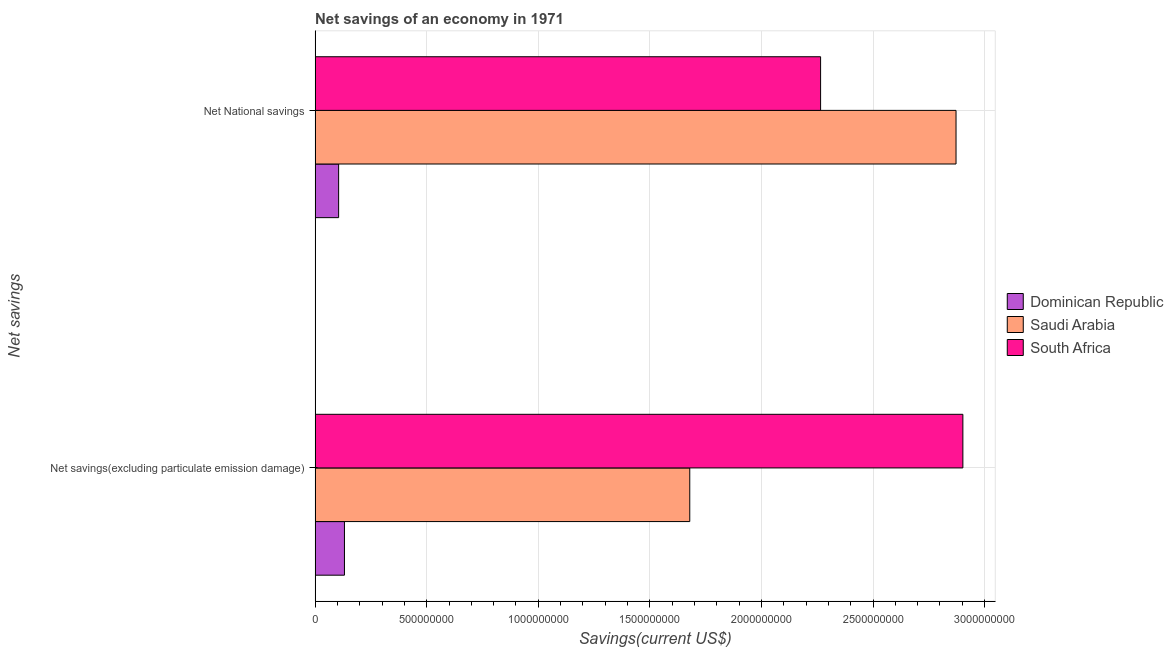How many groups of bars are there?
Ensure brevity in your answer.  2. Are the number of bars per tick equal to the number of legend labels?
Make the answer very short. Yes. Are the number of bars on each tick of the Y-axis equal?
Your answer should be compact. Yes. What is the label of the 2nd group of bars from the top?
Provide a succinct answer. Net savings(excluding particulate emission damage). What is the net national savings in South Africa?
Your answer should be compact. 2.27e+09. Across all countries, what is the maximum net savings(excluding particulate emission damage)?
Your answer should be very brief. 2.90e+09. Across all countries, what is the minimum net savings(excluding particulate emission damage)?
Provide a succinct answer. 1.32e+08. In which country was the net national savings maximum?
Your answer should be compact. Saudi Arabia. In which country was the net national savings minimum?
Offer a terse response. Dominican Republic. What is the total net national savings in the graph?
Provide a short and direct response. 5.24e+09. What is the difference between the net savings(excluding particulate emission damage) in Saudi Arabia and that in Dominican Republic?
Make the answer very short. 1.55e+09. What is the difference between the net national savings in South Africa and the net savings(excluding particulate emission damage) in Saudi Arabia?
Your answer should be compact. 5.86e+08. What is the average net savings(excluding particulate emission damage) per country?
Keep it short and to the point. 1.57e+09. What is the difference between the net national savings and net savings(excluding particulate emission damage) in South Africa?
Your answer should be very brief. -6.38e+08. In how many countries, is the net savings(excluding particulate emission damage) greater than 1200000000 US$?
Provide a short and direct response. 2. What is the ratio of the net national savings in Saudi Arabia to that in South Africa?
Your answer should be compact. 1.27. Is the net savings(excluding particulate emission damage) in South Africa less than that in Dominican Republic?
Offer a very short reply. No. What does the 1st bar from the top in Net National savings represents?
Provide a short and direct response. South Africa. What does the 2nd bar from the bottom in Net National savings represents?
Give a very brief answer. Saudi Arabia. How many bars are there?
Give a very brief answer. 6. Are all the bars in the graph horizontal?
Ensure brevity in your answer.  Yes. Are the values on the major ticks of X-axis written in scientific E-notation?
Offer a very short reply. No. How many legend labels are there?
Provide a short and direct response. 3. How are the legend labels stacked?
Give a very brief answer. Vertical. What is the title of the graph?
Make the answer very short. Net savings of an economy in 1971. What is the label or title of the X-axis?
Offer a very short reply. Savings(current US$). What is the label or title of the Y-axis?
Your response must be concise. Net savings. What is the Savings(current US$) of Dominican Republic in Net savings(excluding particulate emission damage)?
Your response must be concise. 1.32e+08. What is the Savings(current US$) of Saudi Arabia in Net savings(excluding particulate emission damage)?
Keep it short and to the point. 1.68e+09. What is the Savings(current US$) of South Africa in Net savings(excluding particulate emission damage)?
Give a very brief answer. 2.90e+09. What is the Savings(current US$) in Dominican Republic in Net National savings?
Provide a short and direct response. 1.05e+08. What is the Savings(current US$) of Saudi Arabia in Net National savings?
Offer a very short reply. 2.87e+09. What is the Savings(current US$) in South Africa in Net National savings?
Provide a succinct answer. 2.27e+09. Across all Net savings, what is the maximum Savings(current US$) of Dominican Republic?
Your answer should be compact. 1.32e+08. Across all Net savings, what is the maximum Savings(current US$) of Saudi Arabia?
Make the answer very short. 2.87e+09. Across all Net savings, what is the maximum Savings(current US$) in South Africa?
Make the answer very short. 2.90e+09. Across all Net savings, what is the minimum Savings(current US$) of Dominican Republic?
Make the answer very short. 1.05e+08. Across all Net savings, what is the minimum Savings(current US$) of Saudi Arabia?
Provide a succinct answer. 1.68e+09. Across all Net savings, what is the minimum Savings(current US$) in South Africa?
Your answer should be very brief. 2.27e+09. What is the total Savings(current US$) of Dominican Republic in the graph?
Offer a terse response. 2.37e+08. What is the total Savings(current US$) of Saudi Arabia in the graph?
Make the answer very short. 4.55e+09. What is the total Savings(current US$) in South Africa in the graph?
Ensure brevity in your answer.  5.17e+09. What is the difference between the Savings(current US$) in Dominican Republic in Net savings(excluding particulate emission damage) and that in Net National savings?
Your response must be concise. 2.61e+07. What is the difference between the Savings(current US$) in Saudi Arabia in Net savings(excluding particulate emission damage) and that in Net National savings?
Offer a terse response. -1.19e+09. What is the difference between the Savings(current US$) in South Africa in Net savings(excluding particulate emission damage) and that in Net National savings?
Give a very brief answer. 6.38e+08. What is the difference between the Savings(current US$) of Dominican Republic in Net savings(excluding particulate emission damage) and the Savings(current US$) of Saudi Arabia in Net National savings?
Provide a succinct answer. -2.74e+09. What is the difference between the Savings(current US$) of Dominican Republic in Net savings(excluding particulate emission damage) and the Savings(current US$) of South Africa in Net National savings?
Offer a very short reply. -2.13e+09. What is the difference between the Savings(current US$) of Saudi Arabia in Net savings(excluding particulate emission damage) and the Savings(current US$) of South Africa in Net National savings?
Your answer should be compact. -5.86e+08. What is the average Savings(current US$) in Dominican Republic per Net savings?
Your answer should be very brief. 1.18e+08. What is the average Savings(current US$) of Saudi Arabia per Net savings?
Ensure brevity in your answer.  2.28e+09. What is the average Savings(current US$) in South Africa per Net savings?
Your response must be concise. 2.58e+09. What is the difference between the Savings(current US$) of Dominican Republic and Savings(current US$) of Saudi Arabia in Net savings(excluding particulate emission damage)?
Provide a short and direct response. -1.55e+09. What is the difference between the Savings(current US$) in Dominican Republic and Savings(current US$) in South Africa in Net savings(excluding particulate emission damage)?
Your answer should be very brief. -2.77e+09. What is the difference between the Savings(current US$) in Saudi Arabia and Savings(current US$) in South Africa in Net savings(excluding particulate emission damage)?
Provide a succinct answer. -1.22e+09. What is the difference between the Savings(current US$) of Dominican Republic and Savings(current US$) of Saudi Arabia in Net National savings?
Your answer should be very brief. -2.77e+09. What is the difference between the Savings(current US$) in Dominican Republic and Savings(current US$) in South Africa in Net National savings?
Provide a succinct answer. -2.16e+09. What is the difference between the Savings(current US$) of Saudi Arabia and Savings(current US$) of South Africa in Net National savings?
Make the answer very short. 6.07e+08. What is the ratio of the Savings(current US$) in Dominican Republic in Net savings(excluding particulate emission damage) to that in Net National savings?
Offer a very short reply. 1.25. What is the ratio of the Savings(current US$) of Saudi Arabia in Net savings(excluding particulate emission damage) to that in Net National savings?
Your answer should be very brief. 0.58. What is the ratio of the Savings(current US$) of South Africa in Net savings(excluding particulate emission damage) to that in Net National savings?
Provide a succinct answer. 1.28. What is the difference between the highest and the second highest Savings(current US$) in Dominican Republic?
Offer a very short reply. 2.61e+07. What is the difference between the highest and the second highest Savings(current US$) in Saudi Arabia?
Offer a terse response. 1.19e+09. What is the difference between the highest and the second highest Savings(current US$) of South Africa?
Provide a short and direct response. 6.38e+08. What is the difference between the highest and the lowest Savings(current US$) of Dominican Republic?
Keep it short and to the point. 2.61e+07. What is the difference between the highest and the lowest Savings(current US$) in Saudi Arabia?
Your response must be concise. 1.19e+09. What is the difference between the highest and the lowest Savings(current US$) of South Africa?
Your answer should be compact. 6.38e+08. 